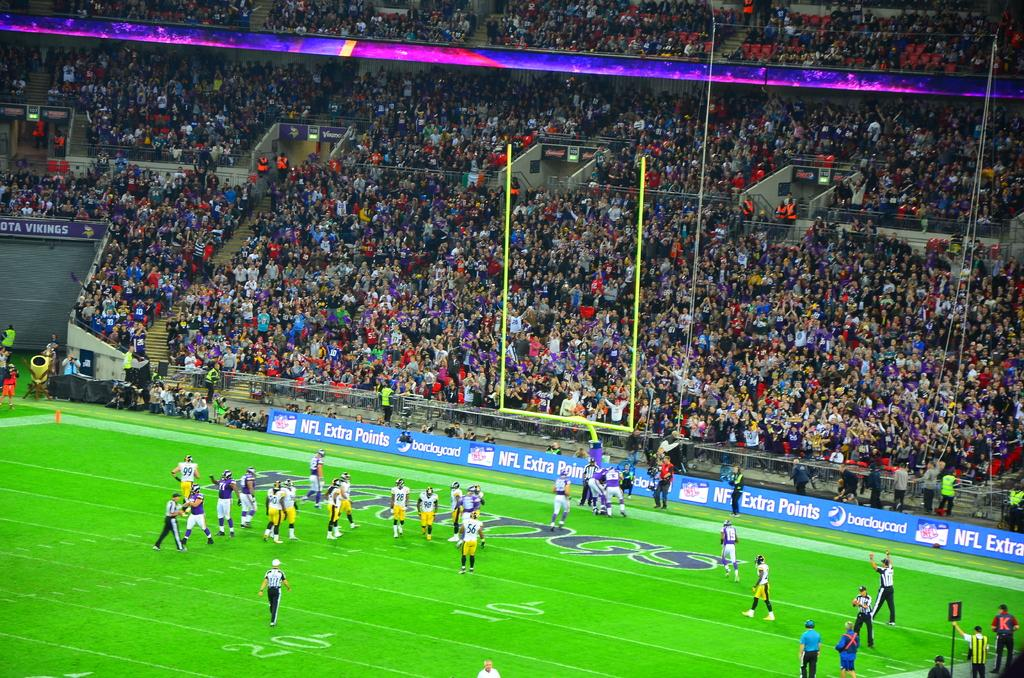<image>
Provide a brief description of the given image. The Minnesota Vikings celebrate after scoring a touchdown against the Pittsburgh Steelers. 